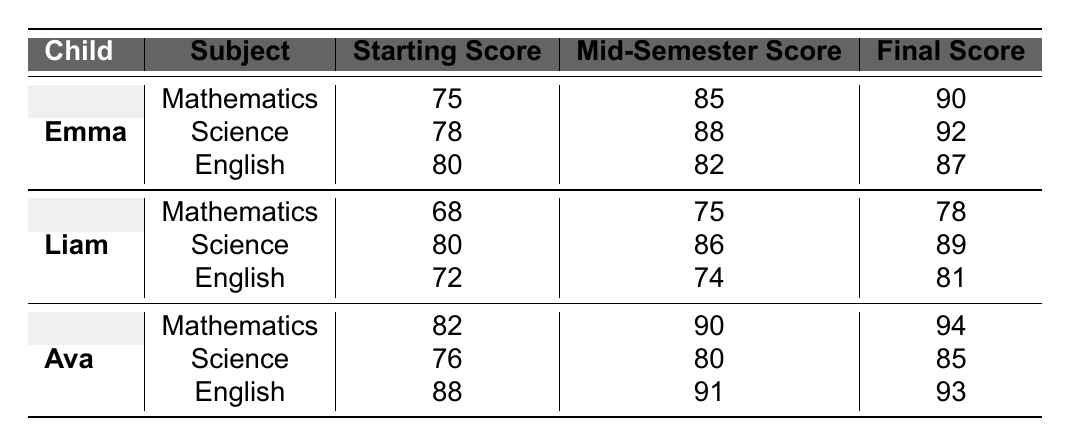What was Emma's final score in Mathematics? The table shows that Emma's final score in Mathematics is listed under the final score column for her Mathematics subject, which is 90.
Answer: 90 What is Liam's mid-semester score in Science? By referring to the table, Liam's mid-semester score in Science can be found in the respective row under the mid-semester score column, which is 86.
Answer: 86 Which child had the highest starting score in English? The starting scores in English for Emma, Liam, and Ava are 80, 72, and 88 respectively. Comparing these values, Ava has the highest starting score of 88.
Answer: Ava What is the difference between Ava's final score in Mathematics and Emma's final score in Mathematics? Ava's final score in Mathematics is 94, while Emma's final score is 90. The difference is 94 - 90 = 4.
Answer: 4 What subject did Liam improve in the most from his starting score to his final score? The improvement for each subject for Liam is as follows: Mathematics (68 to 78), Science (80 to 89), and English (72 to 81). The improvements are 10, 9, and 9 respectively, indicating the largest improvement is in Mathematics with an increase of 10 points.
Answer: Mathematics What is the average final score for all subjects of Ava? The final scores for Ava are Mathematics (94), Science (85), and English (93). The average is (94 + 85 + 93) / 3 = 90.67.
Answer: 90.67 Did Emma score above 80 in all subjects at mid-semester? At mid-semester, Emma's scores were Mathematics (85), Science (88), and English (82). Since all scores are above 80, the answer is yes.
Answer: Yes Which child had the lowest final score overall? Comparing the final scores: Emma (90), Liam (81), and Ava (94), Liam has the lowest final score of 81.
Answer: Liam What was the total improvement in Science scores for each child from starting to final? Emma improved by 14 (78 to 92), Liam improved by 9 (80 to 89), and Ava improved by 9 (76 to 85), leading to total improvements of 14 + 9 + 9 = 32 across all three children.
Answer: 32 Which subject had the highest starting score among all children? The highest starting scores are: Mathematics (82 for Ava), Science (80 for Liam), and English (88 for Ava). The highest starting score among all subjects is 88 in English by Ava.
Answer: 88 